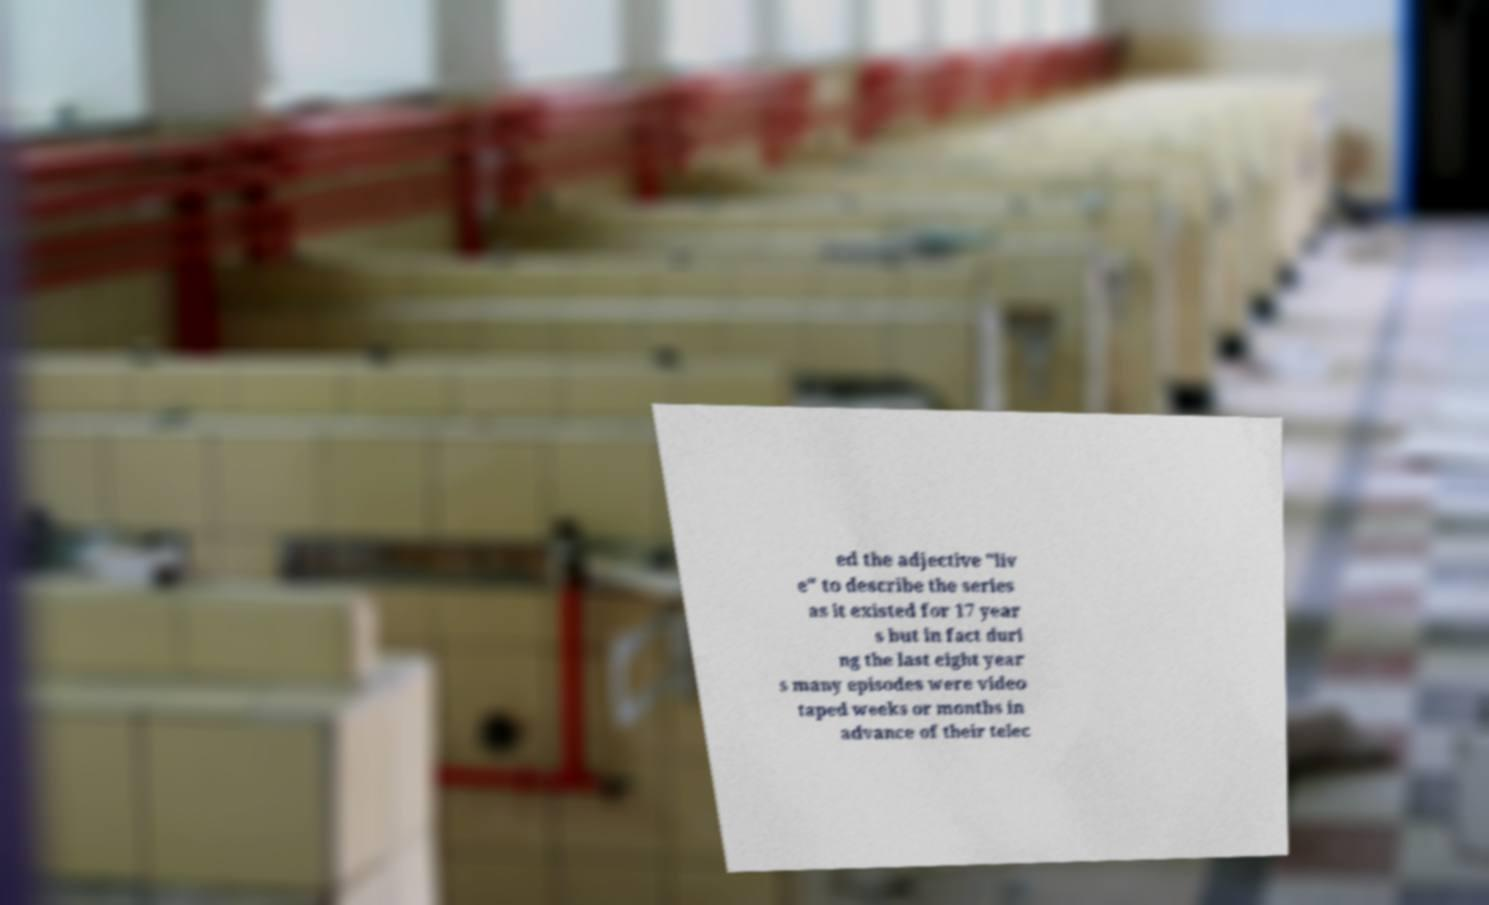Could you extract and type out the text from this image? ed the adjective "liv e" to describe the series as it existed for 17 year s but in fact duri ng the last eight year s many episodes were video taped weeks or months in advance of their telec 